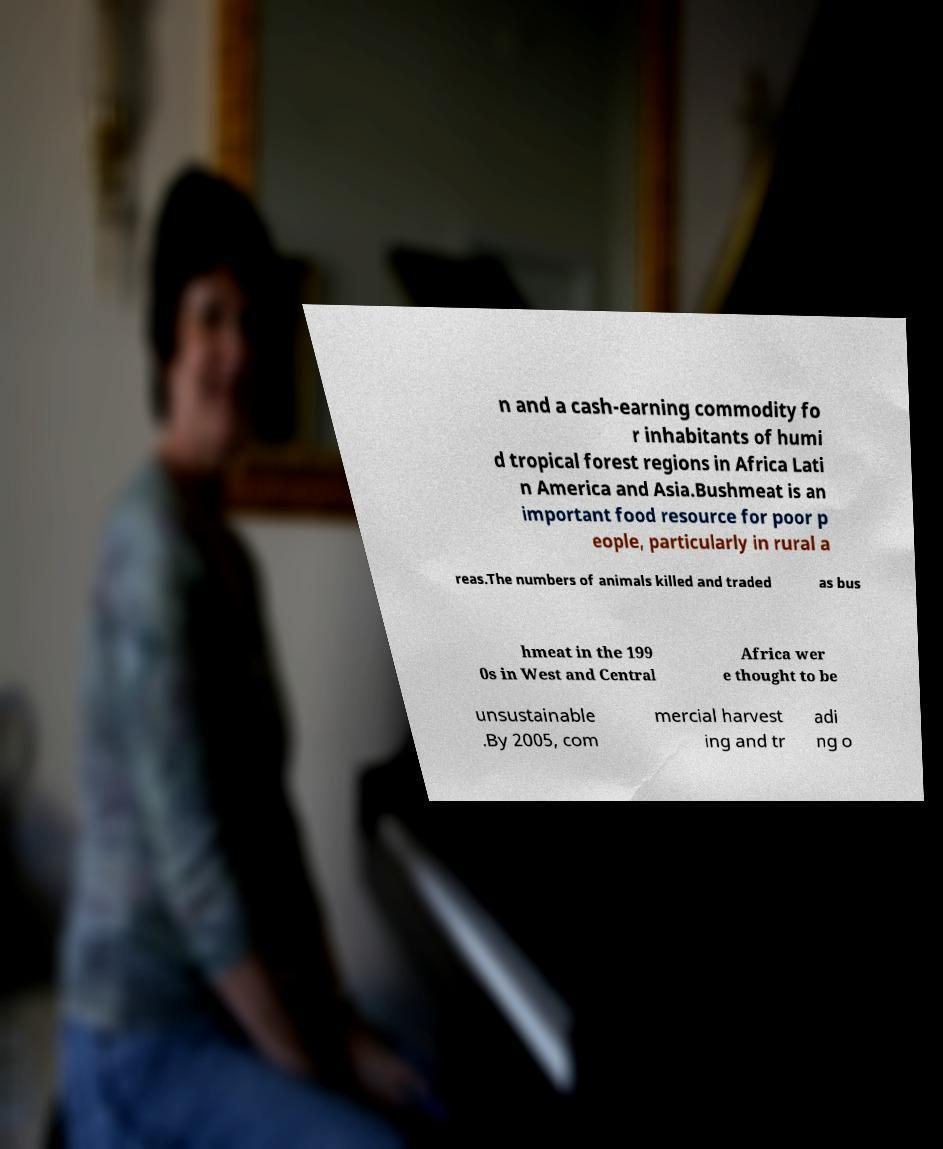I need the written content from this picture converted into text. Can you do that? n and a cash-earning commodity fo r inhabitants of humi d tropical forest regions in Africa Lati n America and Asia.Bushmeat is an important food resource for poor p eople, particularly in rural a reas.The numbers of animals killed and traded as bus hmeat in the 199 0s in West and Central Africa wer e thought to be unsustainable .By 2005, com mercial harvest ing and tr adi ng o 